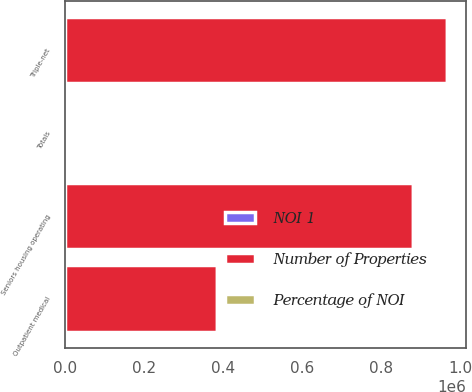<chart> <loc_0><loc_0><loc_500><loc_500><stacked_bar_chart><ecel><fcel>Triple-net<fcel>Seniors housing operating<fcel>Outpatient medical<fcel>Totals<nl><fcel>Number of Properties<fcel>967084<fcel>880026<fcel>384068<fcel>443<nl><fcel>NOI 1<fcel>43.3<fcel>39.5<fcel>17.2<fcel>100<nl><fcel>Percentage of NOI<fcel>573<fcel>443<fcel>270<fcel>1286<nl></chart> 